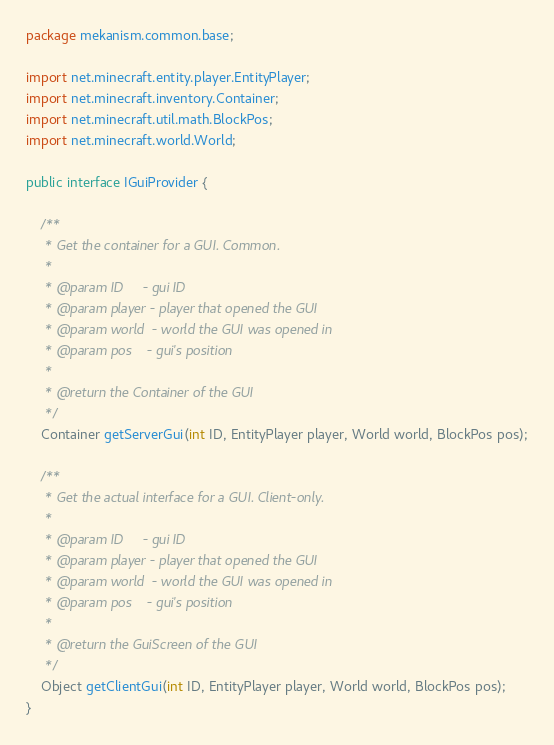<code> <loc_0><loc_0><loc_500><loc_500><_Java_>package mekanism.common.base;

import net.minecraft.entity.player.EntityPlayer;
import net.minecraft.inventory.Container;
import net.minecraft.util.math.BlockPos;
import net.minecraft.world.World;

public interface IGuiProvider {

    /**
     * Get the container for a GUI. Common.
     *
     * @param ID     - gui ID
     * @param player - player that opened the GUI
     * @param world  - world the GUI was opened in
     * @param pos    - gui's position
     *
     * @return the Container of the GUI
     */
    Container getServerGui(int ID, EntityPlayer player, World world, BlockPos pos);

    /**
     * Get the actual interface for a GUI. Client-only.
     *
     * @param ID     - gui ID
     * @param player - player that opened the GUI
     * @param world  - world the GUI was opened in
     * @param pos    - gui's position
     *
     * @return the GuiScreen of the GUI
     */
    Object getClientGui(int ID, EntityPlayer player, World world, BlockPos pos);
}</code> 